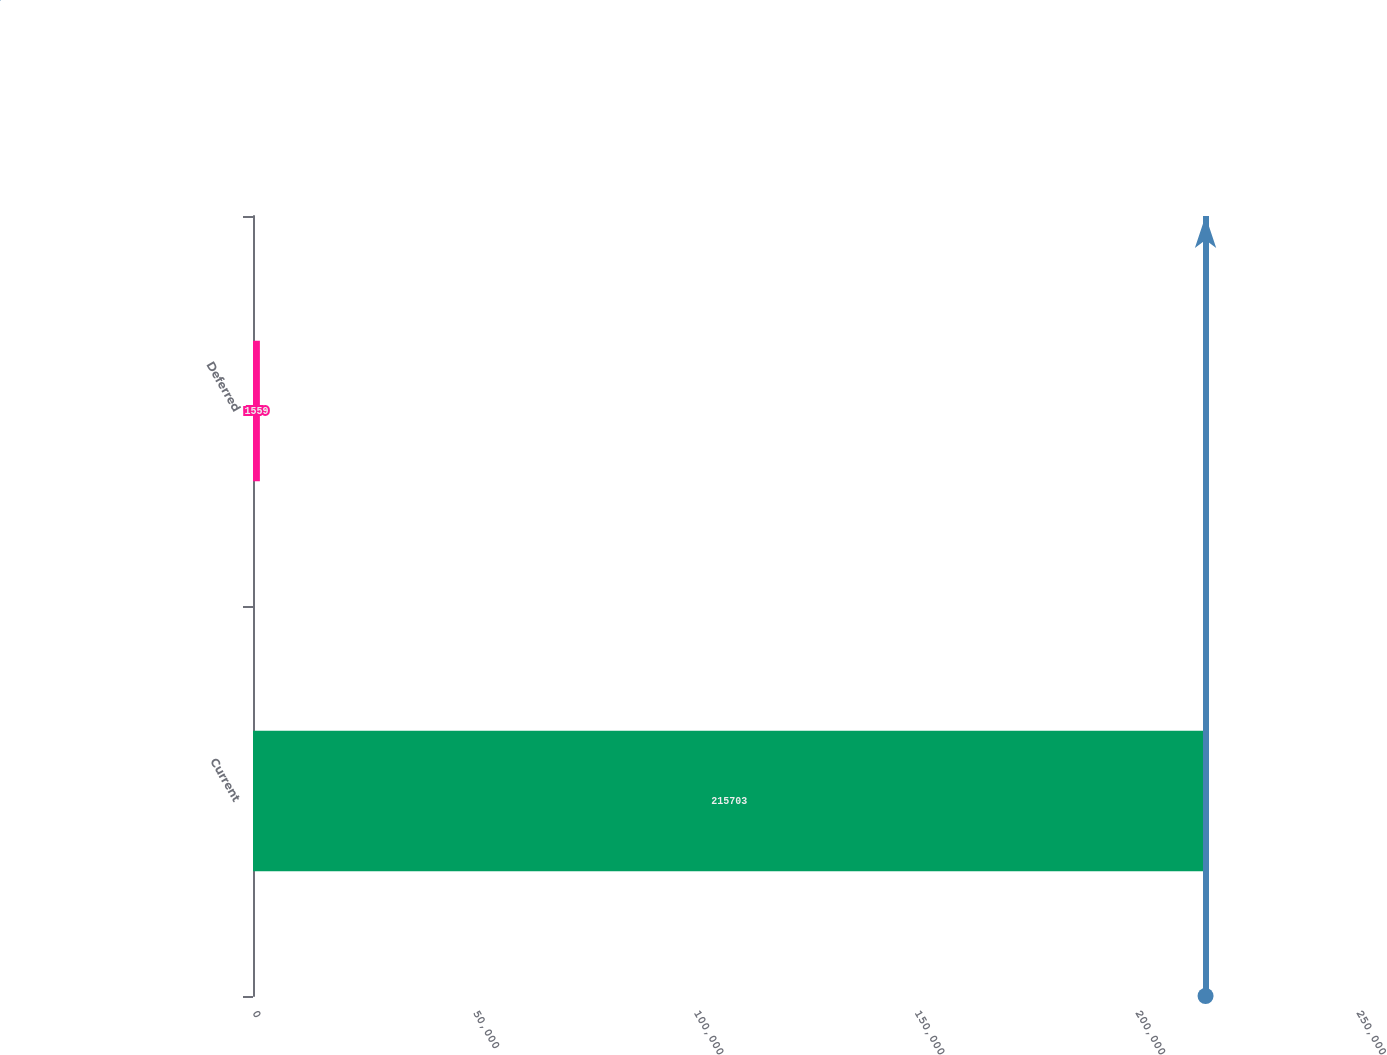Convert chart to OTSL. <chart><loc_0><loc_0><loc_500><loc_500><bar_chart><fcel>Current<fcel>Deferred<nl><fcel>215703<fcel>1559<nl></chart> 